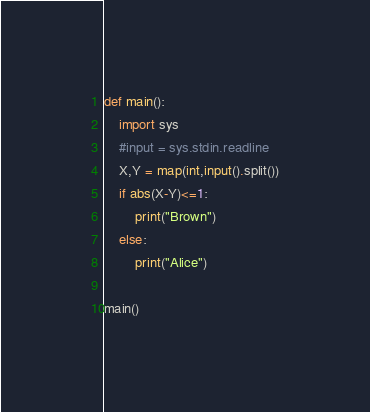Convert code to text. <code><loc_0><loc_0><loc_500><loc_500><_Python_>def main():
    import sys
    #input = sys.stdin.readline
    X,Y = map(int,input().split())
    if abs(X-Y)<=1:
        print("Brown")
    else:
        print("Alice")
    
main()</code> 